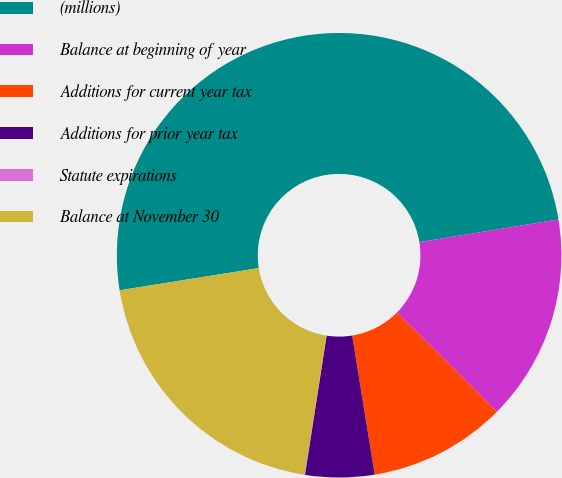Convert chart to OTSL. <chart><loc_0><loc_0><loc_500><loc_500><pie_chart><fcel>(millions)<fcel>Balance at beginning of year<fcel>Additions for current year tax<fcel>Additions for prior year tax<fcel>Statute expirations<fcel>Balance at November 30<nl><fcel>49.94%<fcel>15.0%<fcel>10.01%<fcel>5.02%<fcel>0.03%<fcel>19.99%<nl></chart> 